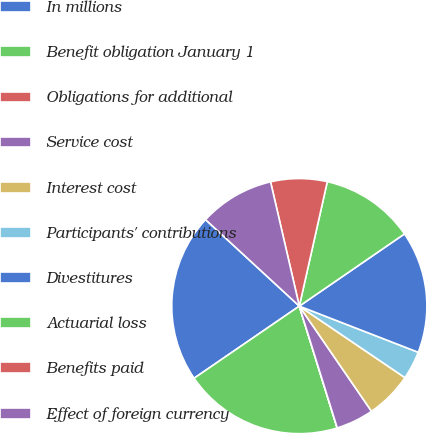Convert chart to OTSL. <chart><loc_0><loc_0><loc_500><loc_500><pie_chart><fcel>In millions<fcel>Benefit obligation January 1<fcel>Obligations for additional<fcel>Service cost<fcel>Interest cost<fcel>Participants' contributions<fcel>Divestitures<fcel>Actuarial loss<fcel>Benefits paid<fcel>Effect of foreign currency<nl><fcel>21.42%<fcel>20.23%<fcel>0.01%<fcel>4.77%<fcel>5.95%<fcel>3.58%<fcel>15.47%<fcel>11.9%<fcel>7.14%<fcel>9.52%<nl></chart> 